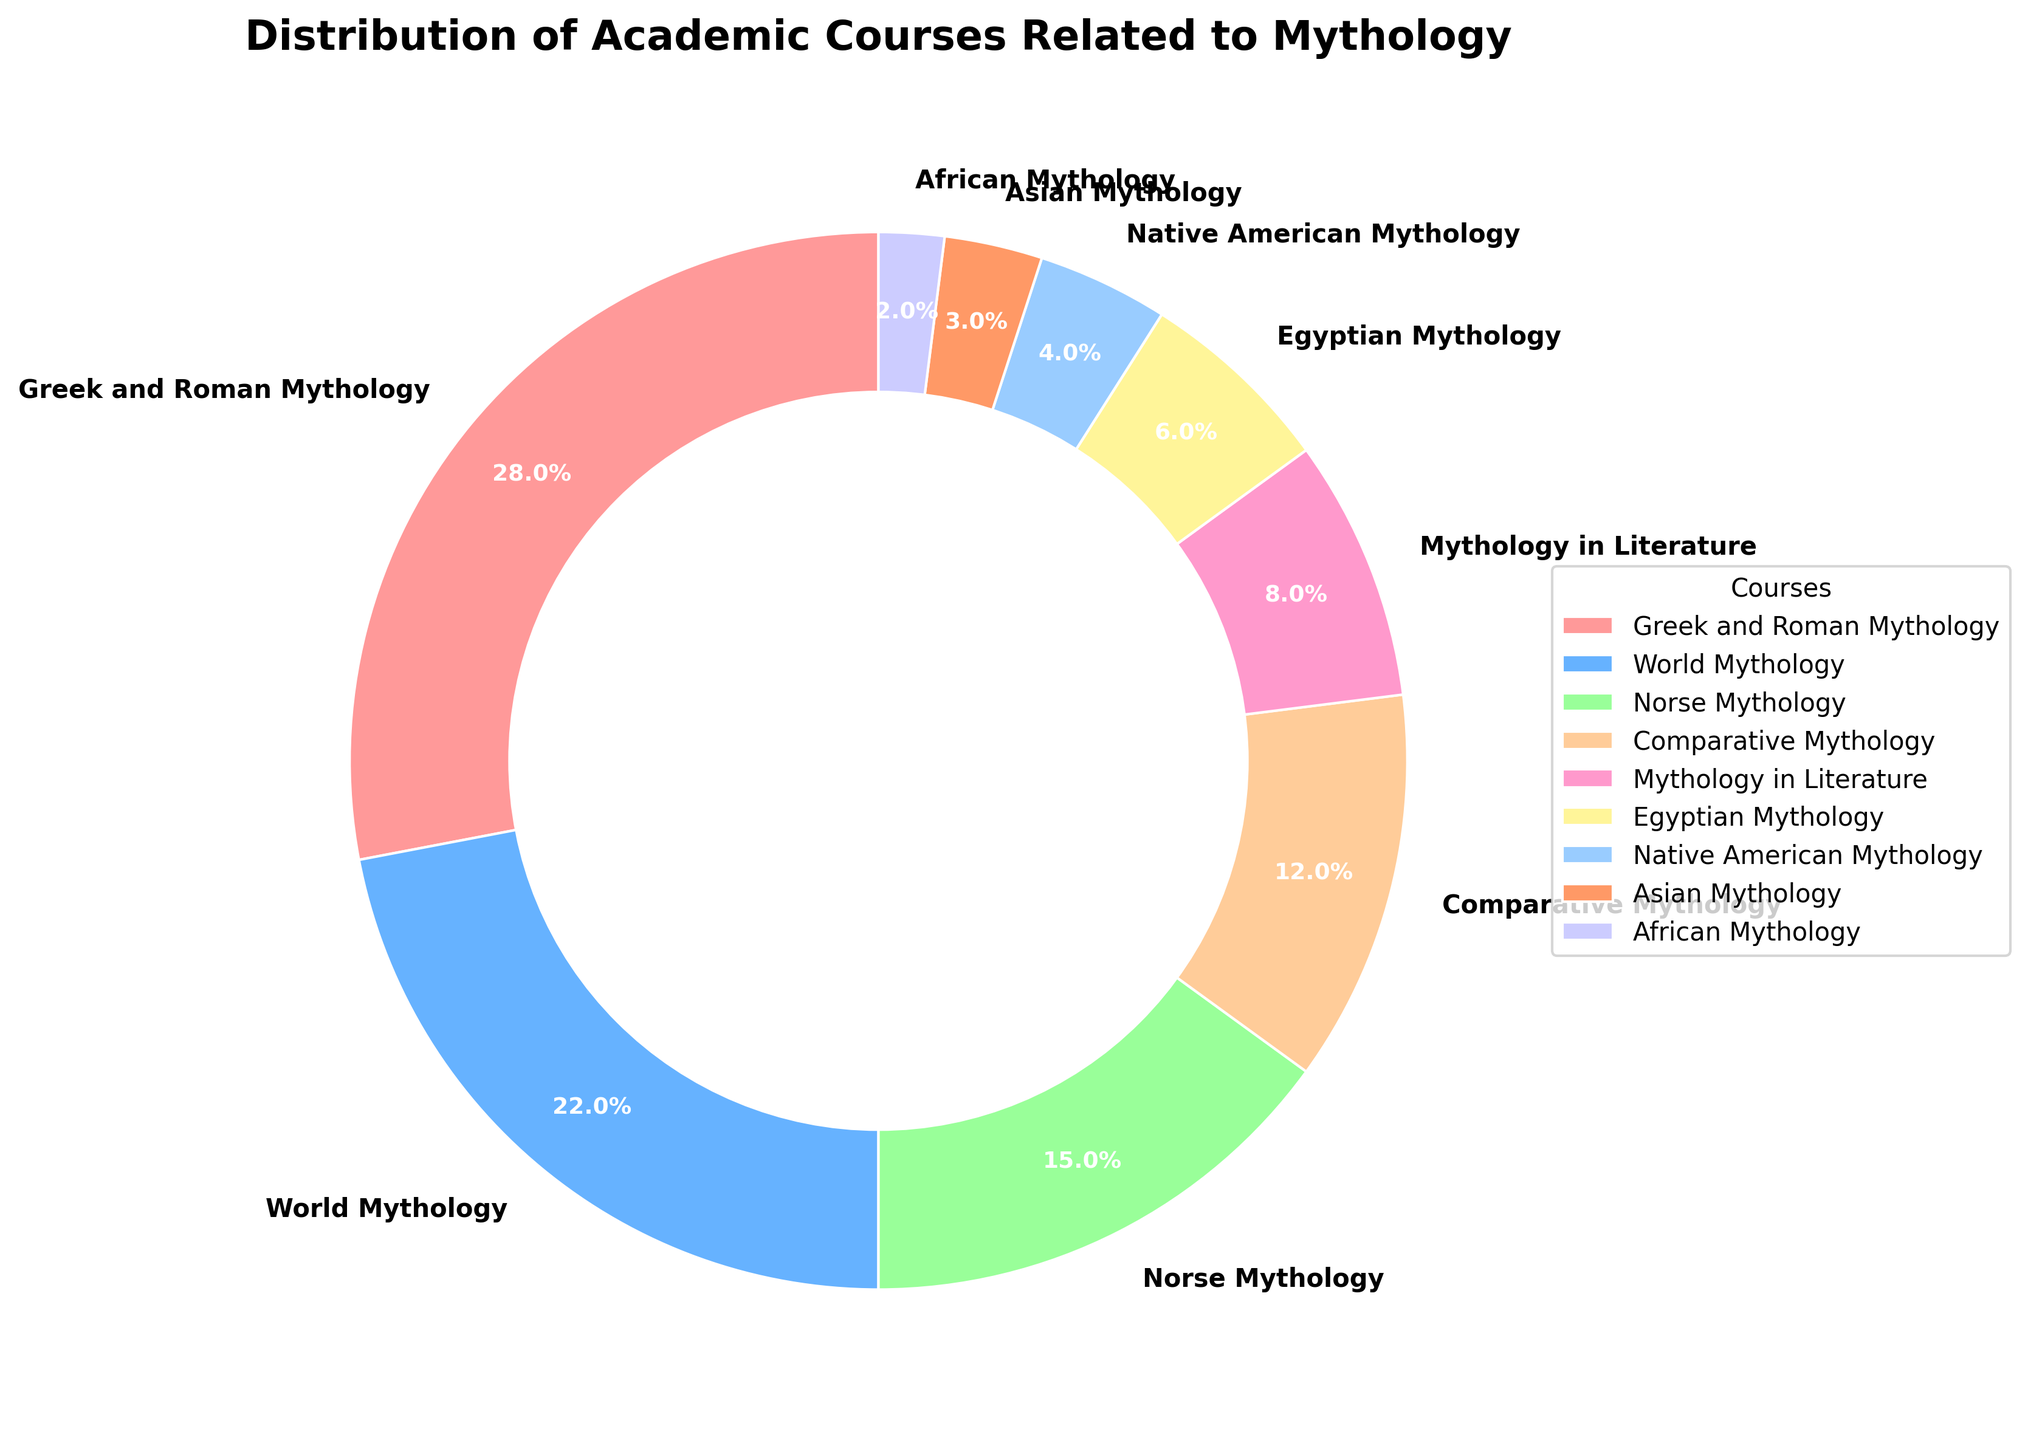What's the most common mythology course offered by top universities? The figure shows different slices representing each mythology course's percentage of the total distribution. The largest slice corresponds to "Greek and Roman Mythology," indicating it has the highest percentage.
Answer: Greek and Roman Mythology Which mythology course is more prevalent: Norse Mythology or Egyptian Mythology? To determine this, compare their slices. The percentage for Norse Mythology is 15%, while for Egyptian Mythology, it is 6%. Norse Mythology has a larger slice.
Answer: Norse Mythology What is the total percentage of courses related to non-Western mythologies (World Mythology, Egyptian Mythology, Native American Mythology, Asian Mythology, African Mythology)? Sum the percentages: World Mythology (22%) + Egyptian Mythology (6%) + Native American Mythology (4%) + Asian Mythology (3%) + African Mythology (2%). The total is 37%.
Answer: 37% Which course has the smallest percentage of offerings? The smallest slice corresponds to African Mythology, which has a percentage of 2%.
Answer: African Mythology Do courses related to Mythology in Literature make up more than 10% of the offerings? Find the Mythology in Literature slice, which is marked as 8%. Since 8% is less than 10%, the answer is no.
Answer: No How does the prevalence of Egyptian Mythology compare to that of Asian Mythology? Egyptian Mythology (6%) and Asian Mythology (3%) are represented by their respective slices. Egyptian Mythology is twice as prevalent as Asian Mythology.
Answer: Egyptian Mythology is more prevalent Calculate the combined percentage of Greek and Roman Mythology and Norse Mythology. Sum their percentages: Greek and Roman Mythology (28%) + Norse Mythology (15%). The combined percentage is 43%.
Answer: 43% Which two mythology courses together cover more than a quarter of the total offerings? Look for courses whose combined percentages exceed 25%. Greek and Roman Mythology (28%) alone exceeds 25%, so adding any course to it will suffice. For a combination, Norse Mythology (15%) plus World Mythology (22%) equals 37%, which exceeds 25%.
Answer: World Mythology and Norse Mythology What is the average percentage of the courses listed? Total percentage is 100%. There are 9 courses. Average = Total / Number of courses: 100 / 9 ≈ 11.1%.
Answer: Approximately 11.1% Which mythology courses together make up less than 10% of the total offerings? Identify courses with small slices that together total less than 10%. Asian Mythology (3%) + African Mythology (2%) = 5%. Adding Native American Mythology (4%) makes it 9%, which is still under 10%.
Answer: Asian Mythology, African Mythology, and Native American Mythology 